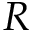<formula> <loc_0><loc_0><loc_500><loc_500>R</formula> 